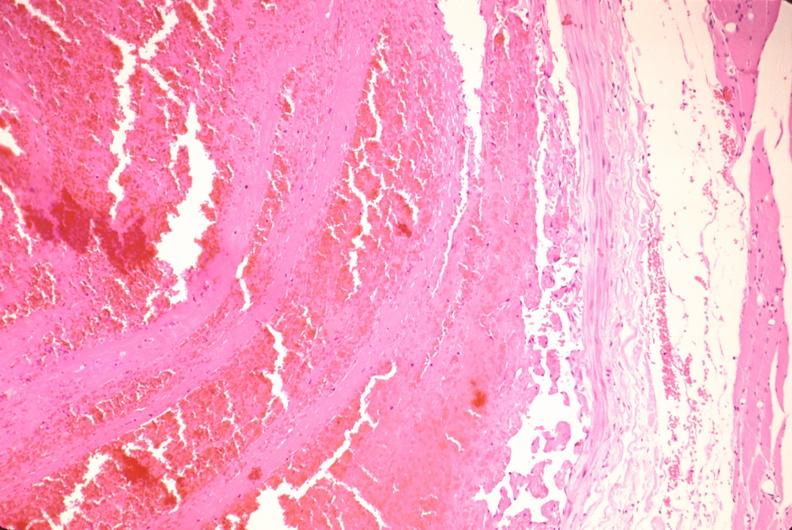s fibrinous peritonitis present?
Answer the question using a single word or phrase. No 